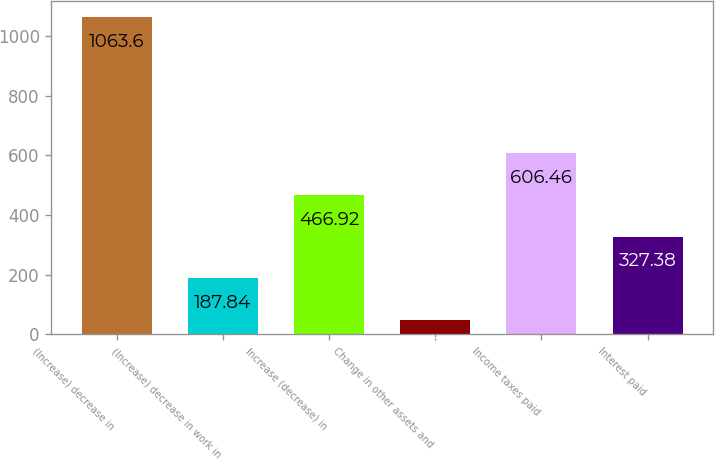Convert chart to OTSL. <chart><loc_0><loc_0><loc_500><loc_500><bar_chart><fcel>(Increase) decrease in<fcel>(Increase) decrease in work in<fcel>Increase (decrease) in<fcel>Change in other assets and<fcel>Income taxes paid<fcel>Interest paid<nl><fcel>1063.6<fcel>187.84<fcel>466.92<fcel>48.3<fcel>606.46<fcel>327.38<nl></chart> 